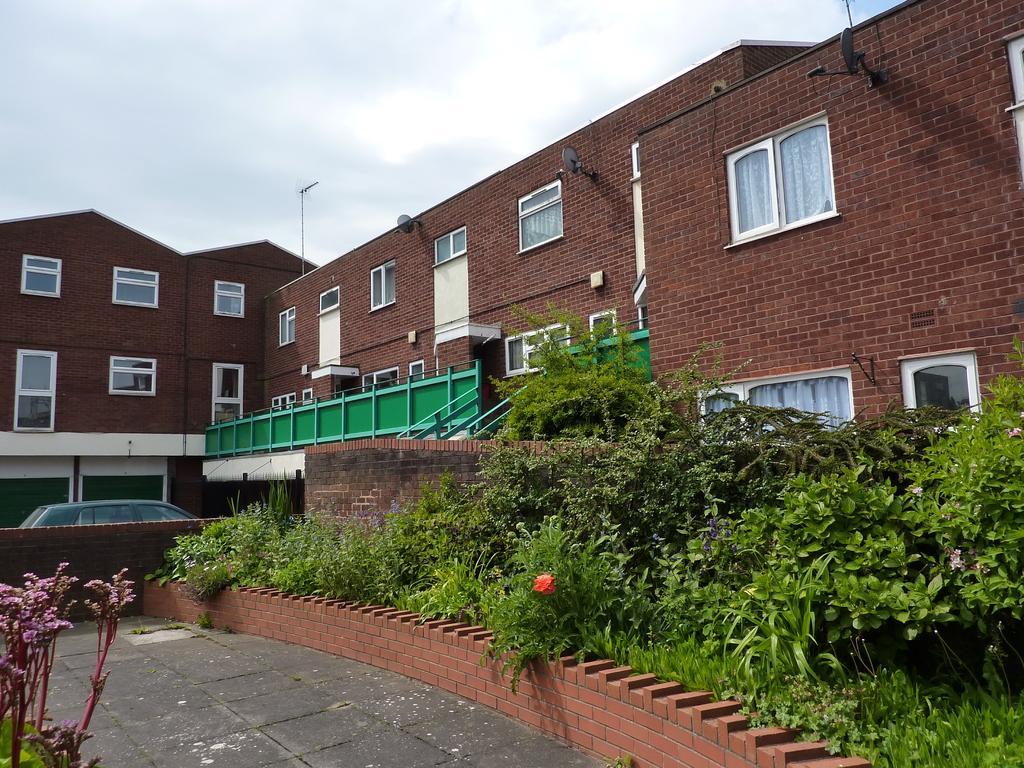Can you describe this image briefly? This picture is clicked outside the sitting. Here we see a building which is made of red color bricks. Beside that, we see staircase and iron railing which is green in color and beside that, we see many trees and plants. In front of the building, we see car and on top of the picture, we see sky. 